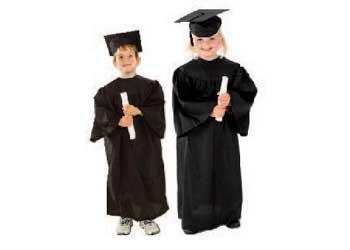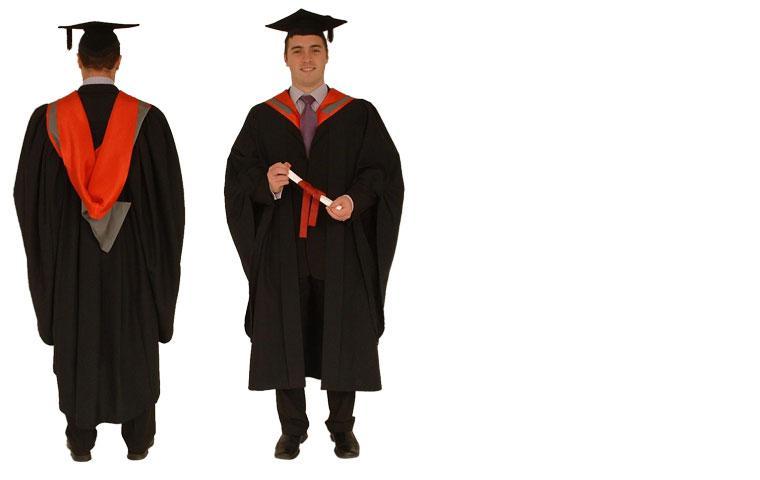The first image is the image on the left, the second image is the image on the right. Considering the images on both sides, is "Each image includes a backward-facing male modeling graduation attire." valid? Answer yes or no. No. The first image is the image on the left, the second image is the image on the right. For the images shown, is this caption "All caps and gowns in the images are modeled by actual people who are shown in full length, from head to toe." true? Answer yes or no. Yes. 